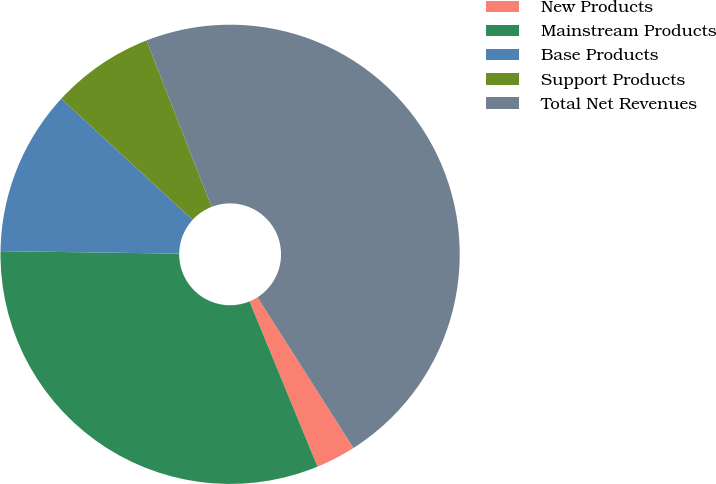<chart> <loc_0><loc_0><loc_500><loc_500><pie_chart><fcel>New Products<fcel>Mainstream Products<fcel>Base Products<fcel>Support Products<fcel>Total Net Revenues<nl><fcel>2.81%<fcel>31.43%<fcel>11.63%<fcel>7.22%<fcel>46.9%<nl></chart> 